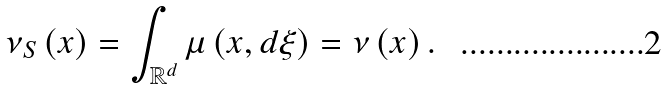<formula> <loc_0><loc_0><loc_500><loc_500>\nu _ { S } \left ( x \right ) = \int _ { \mathbb { R } ^ { d } } \mu \left ( x , d \xi \right ) = \nu \left ( x \right ) .</formula> 